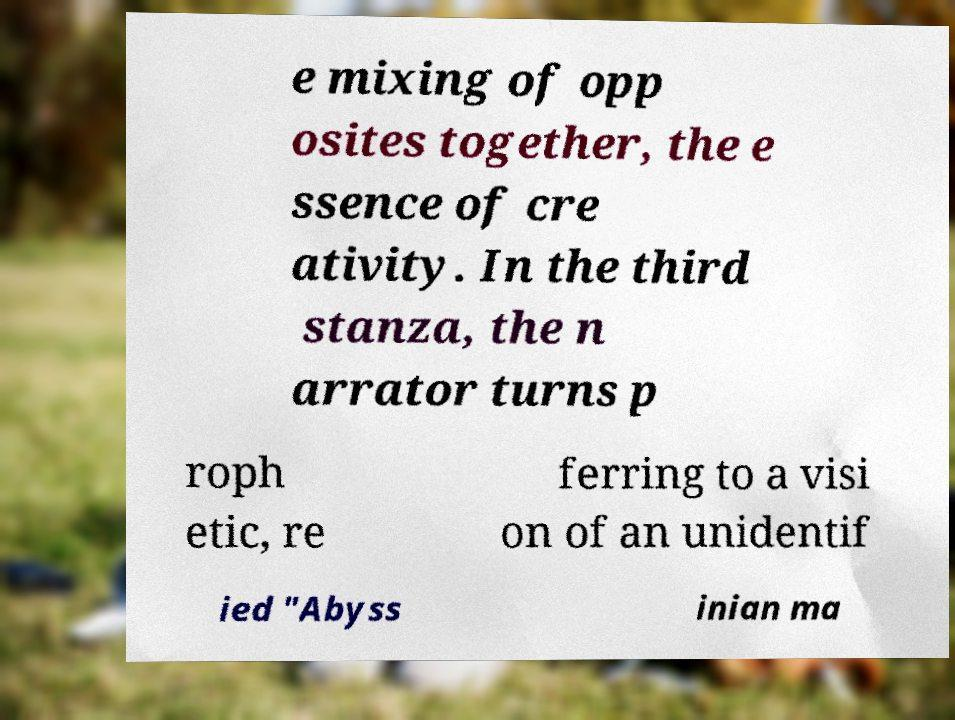There's text embedded in this image that I need extracted. Can you transcribe it verbatim? e mixing of opp osites together, the e ssence of cre ativity. In the third stanza, the n arrator turns p roph etic, re ferring to a visi on of an unidentif ied "Abyss inian ma 